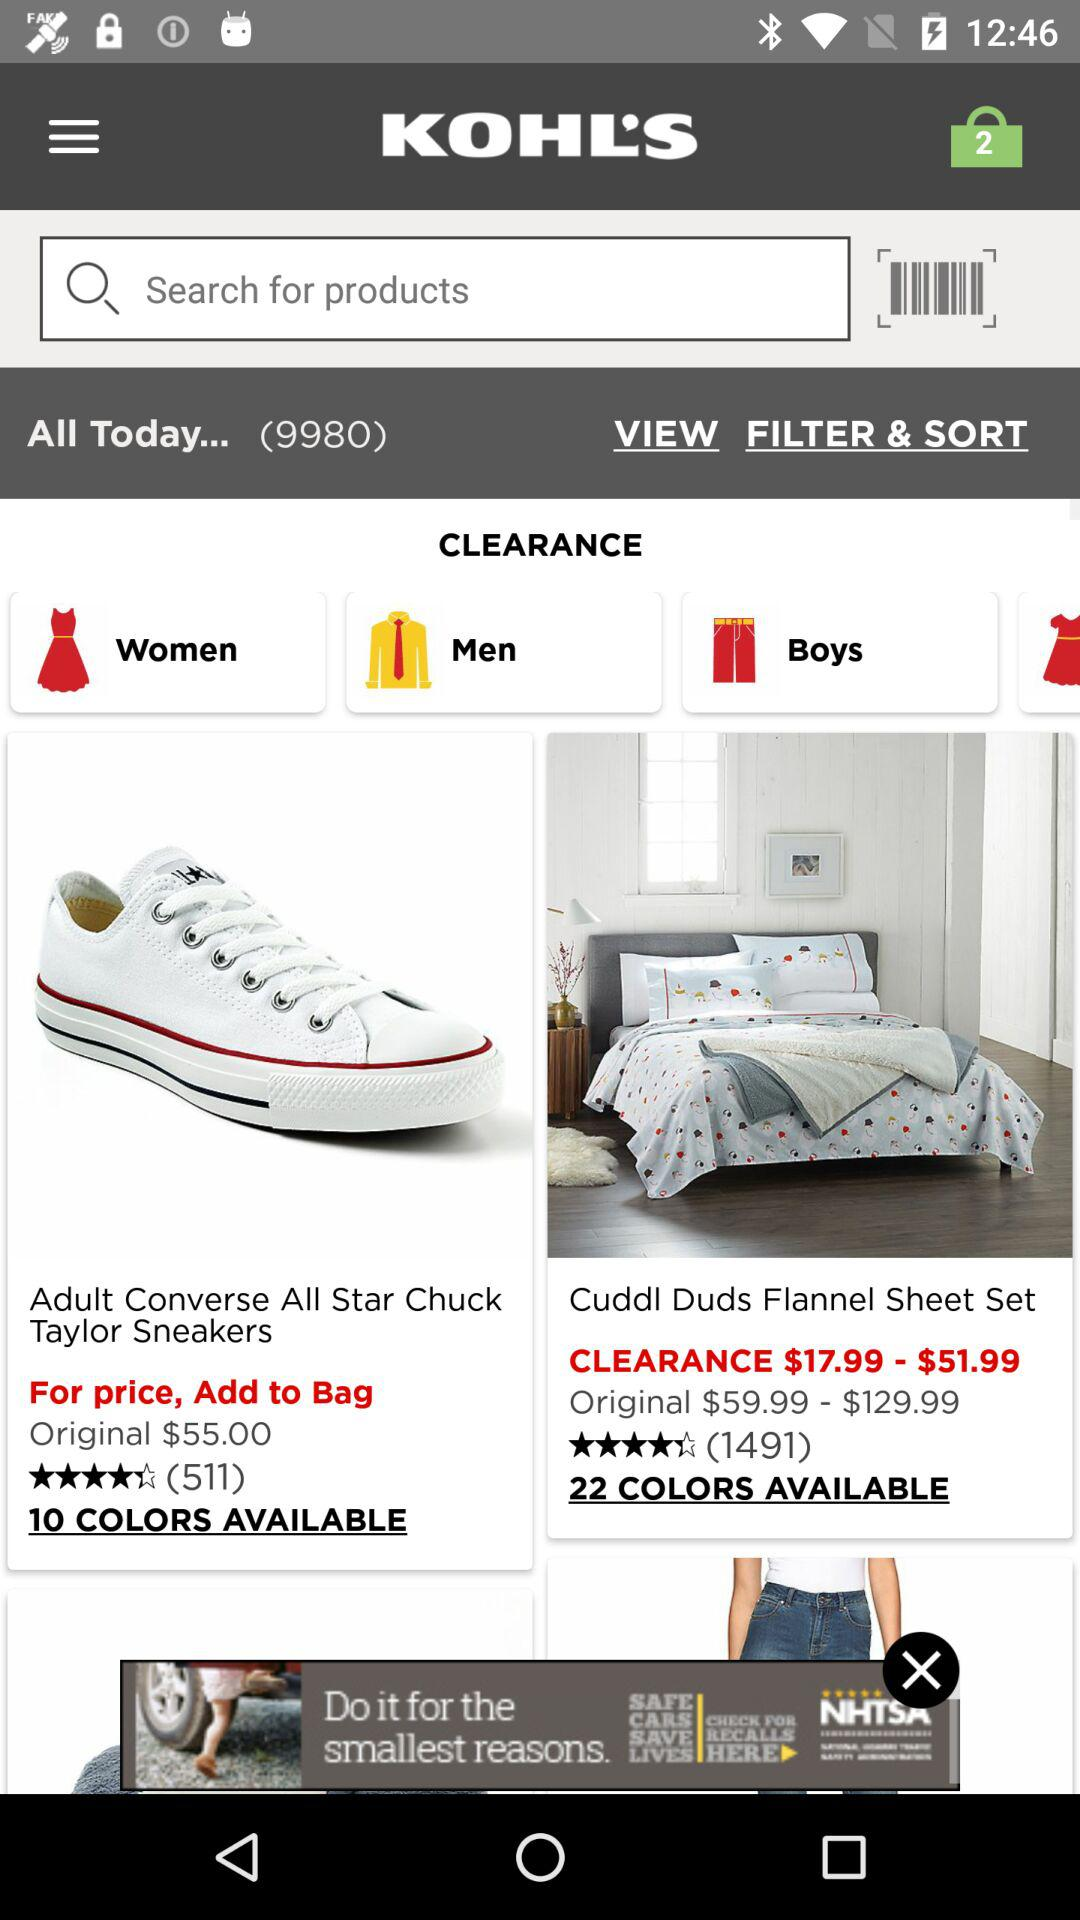How many items are in the bag? There are 2 items in the bag. 